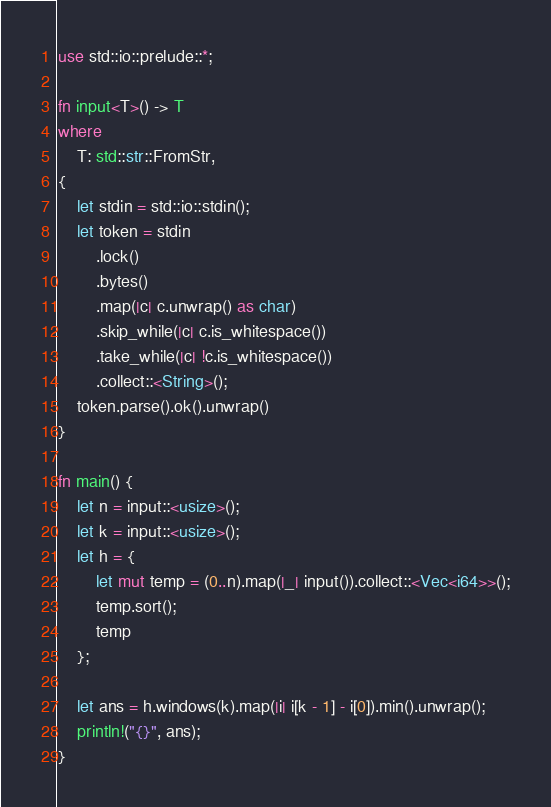Convert code to text. <code><loc_0><loc_0><loc_500><loc_500><_Rust_>use std::io::prelude::*;

fn input<T>() -> T
where
    T: std::str::FromStr,
{
    let stdin = std::io::stdin();
    let token = stdin
        .lock()
        .bytes()
        .map(|c| c.unwrap() as char)
        .skip_while(|c| c.is_whitespace())
        .take_while(|c| !c.is_whitespace())
        .collect::<String>();
    token.parse().ok().unwrap()
}

fn main() {
    let n = input::<usize>();
    let k = input::<usize>();
    let h = {
        let mut temp = (0..n).map(|_| input()).collect::<Vec<i64>>();
        temp.sort();
        temp
    };

    let ans = h.windows(k).map(|i| i[k - 1] - i[0]).min().unwrap();
    println!("{}", ans);
}
</code> 